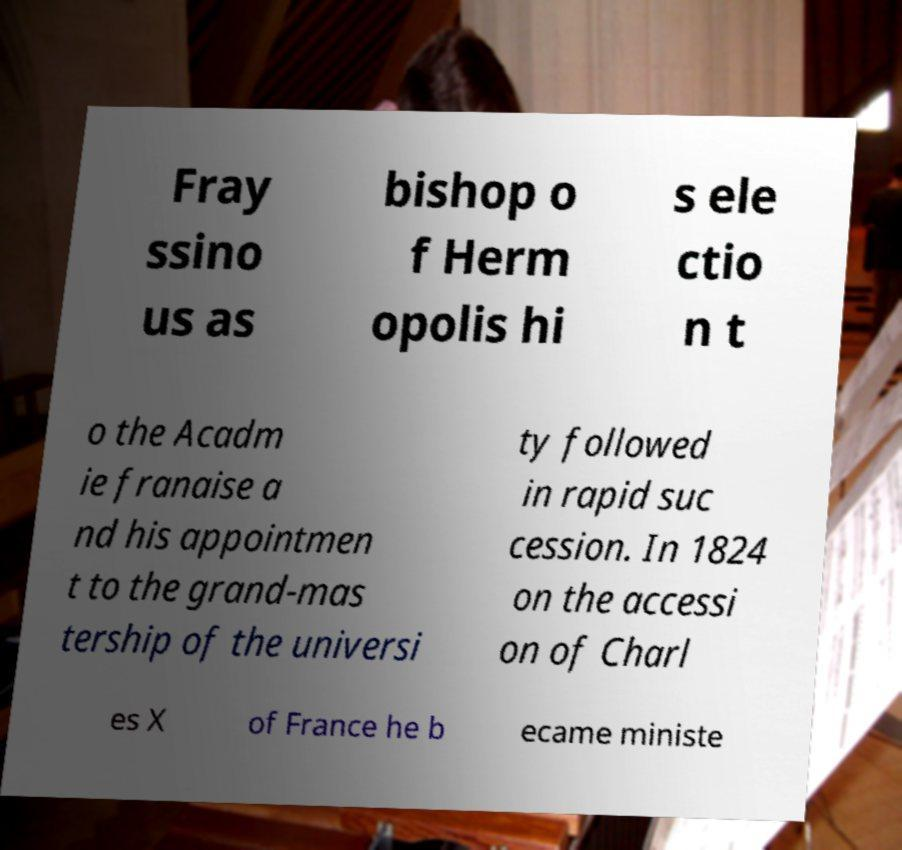I need the written content from this picture converted into text. Can you do that? Fray ssino us as bishop o f Herm opolis hi s ele ctio n t o the Acadm ie franaise a nd his appointmen t to the grand-mas tership of the universi ty followed in rapid suc cession. In 1824 on the accessi on of Charl es X of France he b ecame ministe 